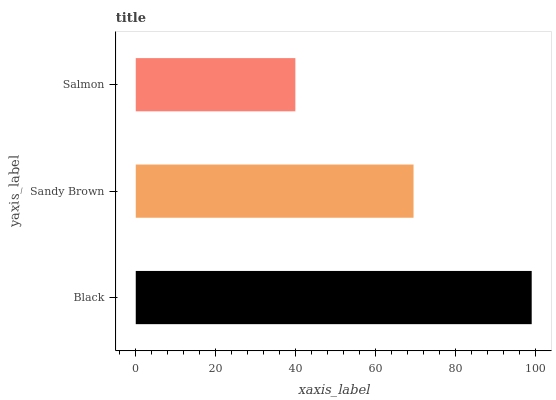Is Salmon the minimum?
Answer yes or no. Yes. Is Black the maximum?
Answer yes or no. Yes. Is Sandy Brown the minimum?
Answer yes or no. No. Is Sandy Brown the maximum?
Answer yes or no. No. Is Black greater than Sandy Brown?
Answer yes or no. Yes. Is Sandy Brown less than Black?
Answer yes or no. Yes. Is Sandy Brown greater than Black?
Answer yes or no. No. Is Black less than Sandy Brown?
Answer yes or no. No. Is Sandy Brown the high median?
Answer yes or no. Yes. Is Sandy Brown the low median?
Answer yes or no. Yes. Is Black the high median?
Answer yes or no. No. Is Black the low median?
Answer yes or no. No. 